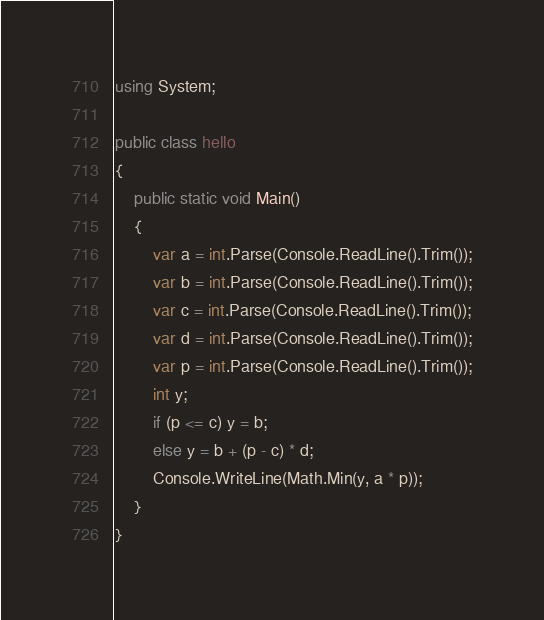<code> <loc_0><loc_0><loc_500><loc_500><_C#_>using System;

public class hello
{
    public static void Main()
    {
        var a = int.Parse(Console.ReadLine().Trim());
        var b = int.Parse(Console.ReadLine().Trim());
        var c = int.Parse(Console.ReadLine().Trim());
        var d = int.Parse(Console.ReadLine().Trim());
        var p = int.Parse(Console.ReadLine().Trim());
        int y;
        if (p <= c) y = b;
        else y = b + (p - c) * d;
        Console.WriteLine(Math.Min(y, a * p));
    }
}</code> 